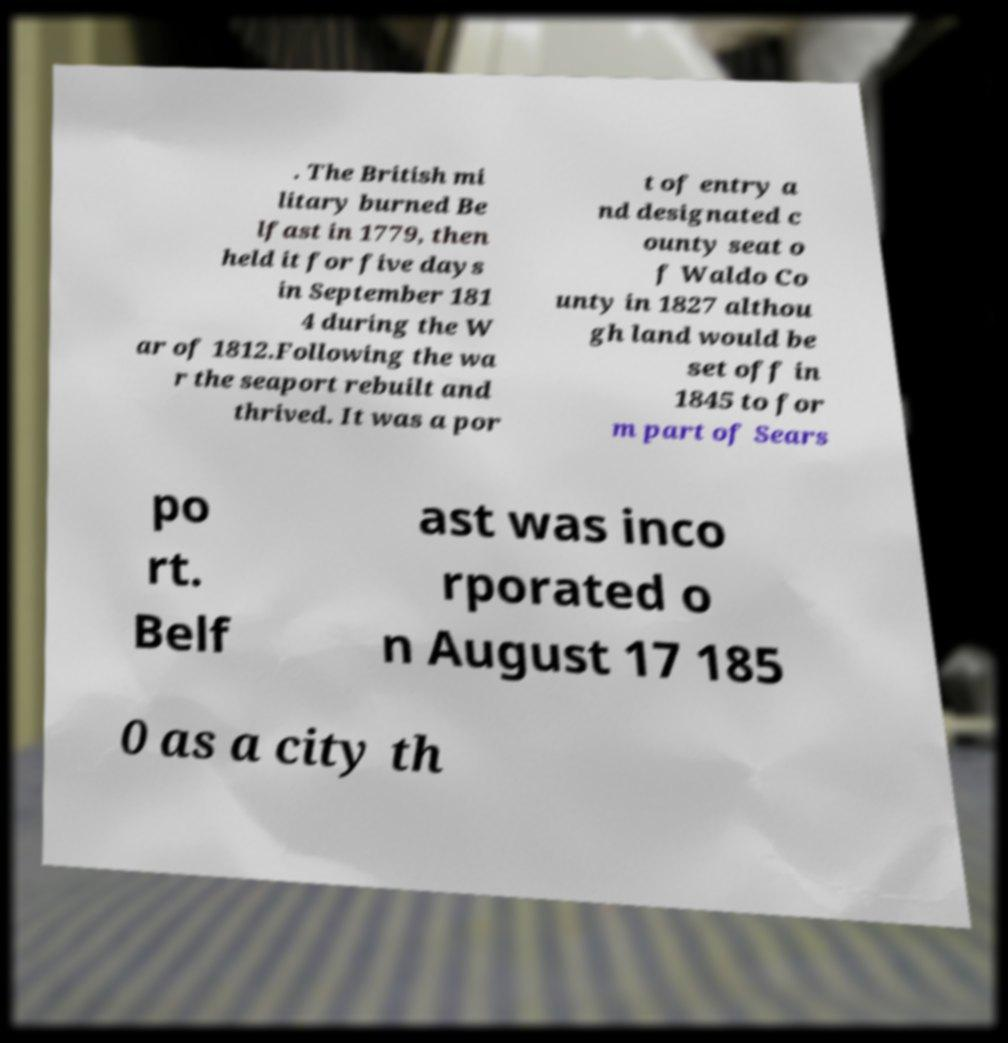Can you accurately transcribe the text from the provided image for me? . The British mi litary burned Be lfast in 1779, then held it for five days in September 181 4 during the W ar of 1812.Following the wa r the seaport rebuilt and thrived. It was a por t of entry a nd designated c ounty seat o f Waldo Co unty in 1827 althou gh land would be set off in 1845 to for m part of Sears po rt. Belf ast was inco rporated o n August 17 185 0 as a city th 